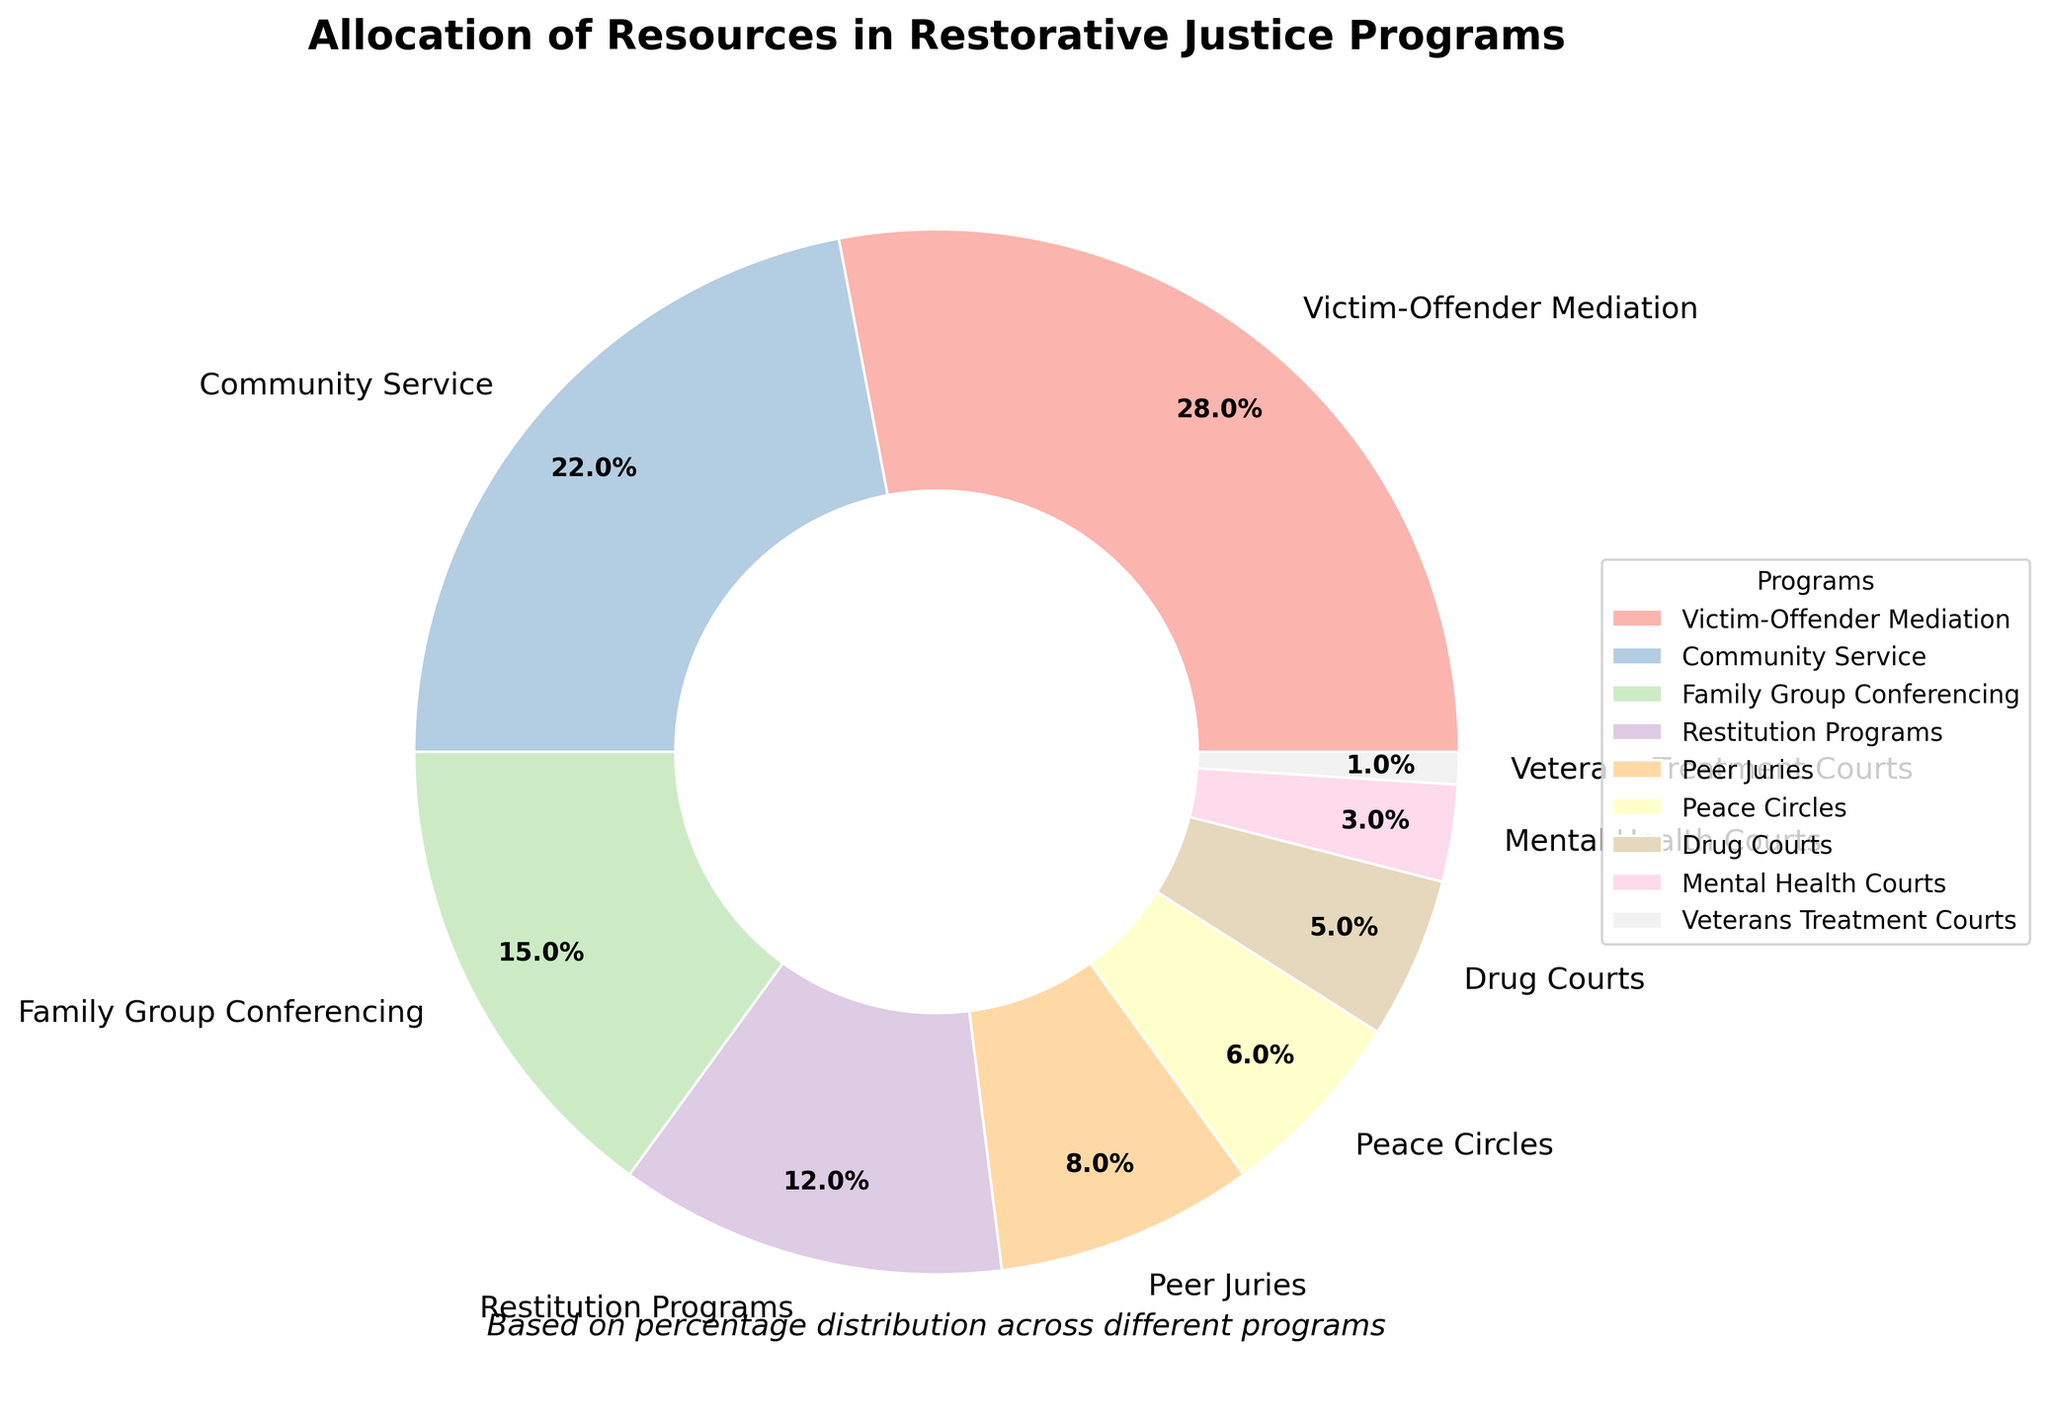Which restorative justice program receives the highest allocation of resources? By looking at the largest wedge in the pie chart and its associated label, we can see that "Victim-Offender Mediation" receives the highest allocation of resources at 28%.
Answer: Victim-Offender Mediation What's the combined percentage allocation for Community Service and Family Group Conferencing programs? To find the combined allocation, we sum the percentages of both programs: 22% (Community Service) + 15% (Family Group Conferencing) = 37%.
Answer: 37% Is the allocation for Restitution Programs greater than that of Peer Juries? We need to compare the two percentages directly: Restitution Programs has 12%, while Peer Juries has 8%. Since 12% is greater than 8%, Restitution Programs has a greater allocation.
Answer: Yes Among the programs with percentages in single digits, which one receives the least resources? By identifying the programs with single-digit allocations (Peer Juries, Peace Circles, Drug Courts, Mental Health Courts, and Veterans Treatment Courts) and comparing their percentages, we see that Veterans Treatment Courts has the smallest allocation at 1%.
Answer: Veterans Treatment Courts What's the total percentage allocation for all restorative justice programs? The pie chart must account for 100% of the allocation. The sum of all individual programs' percentages should equal 100%.
Answer: 100% How much more percentage allocation does Victim-Offender Mediation have compared to Drug Courts? Subtract the percentage allocation of Drug Courts from that of Victim-Offender Mediation: 28% (Victim-Offender Mediation) - 5% (Drug Courts) = 23%.
Answer: 23% If we combine the allocations for Mental Health Courts and Veterans Treatment Courts, does it exceed the allocation for Peace Circles? First, sum the allocations for Mental Health Courts and Veterans Treatment Courts: 3% + 1% = 4%. Then compare it to Peace Circles' 6%. Since 4% is less than 6%, the combined allocation does not exceed Peace Circles.
Answer: No Which program's wedge is labeled at the 9 o'clock position on the pie chart? By examining the placement of wedges and their labels, we observe that the program labeled around the 9 o'clock position is Community Service.
Answer: Community Service 